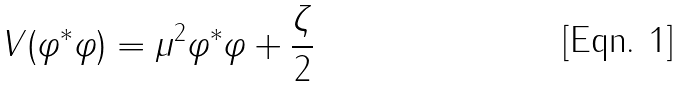<formula> <loc_0><loc_0><loc_500><loc_500>V ( \varphi ^ { \ast } \varphi ) = \mu ^ { 2 } \varphi ^ { \ast } \varphi + \frac { \zeta } { 2 }</formula> 